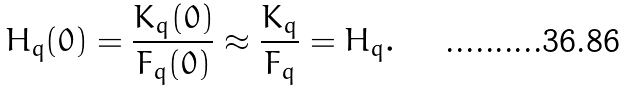Convert formula to latex. <formula><loc_0><loc_0><loc_500><loc_500>H _ { q } ( 0 ) = \frac { K _ { q } ( 0 ) } { F _ { q } ( 0 ) } \approx \frac { K _ { q } } { F _ { q } } = H _ { q } .</formula> 